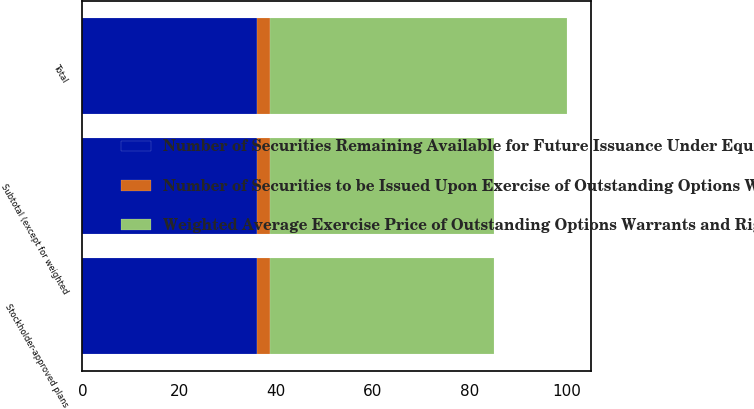Convert chart to OTSL. <chart><loc_0><loc_0><loc_500><loc_500><stacked_bar_chart><ecel><fcel>Stockholder-approved plans<fcel>Subtotal (except for weighted<fcel>Total<nl><fcel>Number of Securities to be Issued Upon Exercise of Outstanding Options Warrants and Rights<fcel>2.7<fcel>2.7<fcel>2.7<nl><fcel>Number of Securities Remaining Available for Future Issuance Under Equity Compensation Plans excluding securities reflected in the first column<fcel>36.11<fcel>36.11<fcel>36.11<nl><fcel>Weighted Average Exercise Price of Outstanding Options Warrants and Rights<fcel>46.2<fcel>46.2<fcel>61.2<nl></chart> 